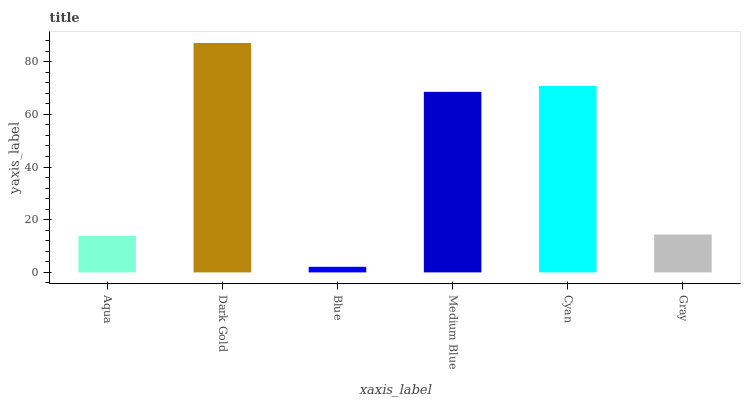Is Blue the minimum?
Answer yes or no. Yes. Is Dark Gold the maximum?
Answer yes or no. Yes. Is Dark Gold the minimum?
Answer yes or no. No. Is Blue the maximum?
Answer yes or no. No. Is Dark Gold greater than Blue?
Answer yes or no. Yes. Is Blue less than Dark Gold?
Answer yes or no. Yes. Is Blue greater than Dark Gold?
Answer yes or no. No. Is Dark Gold less than Blue?
Answer yes or no. No. Is Medium Blue the high median?
Answer yes or no. Yes. Is Gray the low median?
Answer yes or no. Yes. Is Aqua the high median?
Answer yes or no. No. Is Blue the low median?
Answer yes or no. No. 